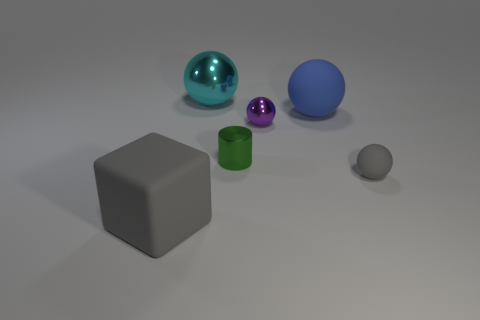Add 4 large blue matte balls. How many objects exist? 10 Subtract all blocks. How many objects are left? 5 Subtract all small red shiny cubes. Subtract all tiny green things. How many objects are left? 5 Add 2 purple spheres. How many purple spheres are left? 3 Add 3 matte balls. How many matte balls exist? 5 Subtract 0 red spheres. How many objects are left? 6 